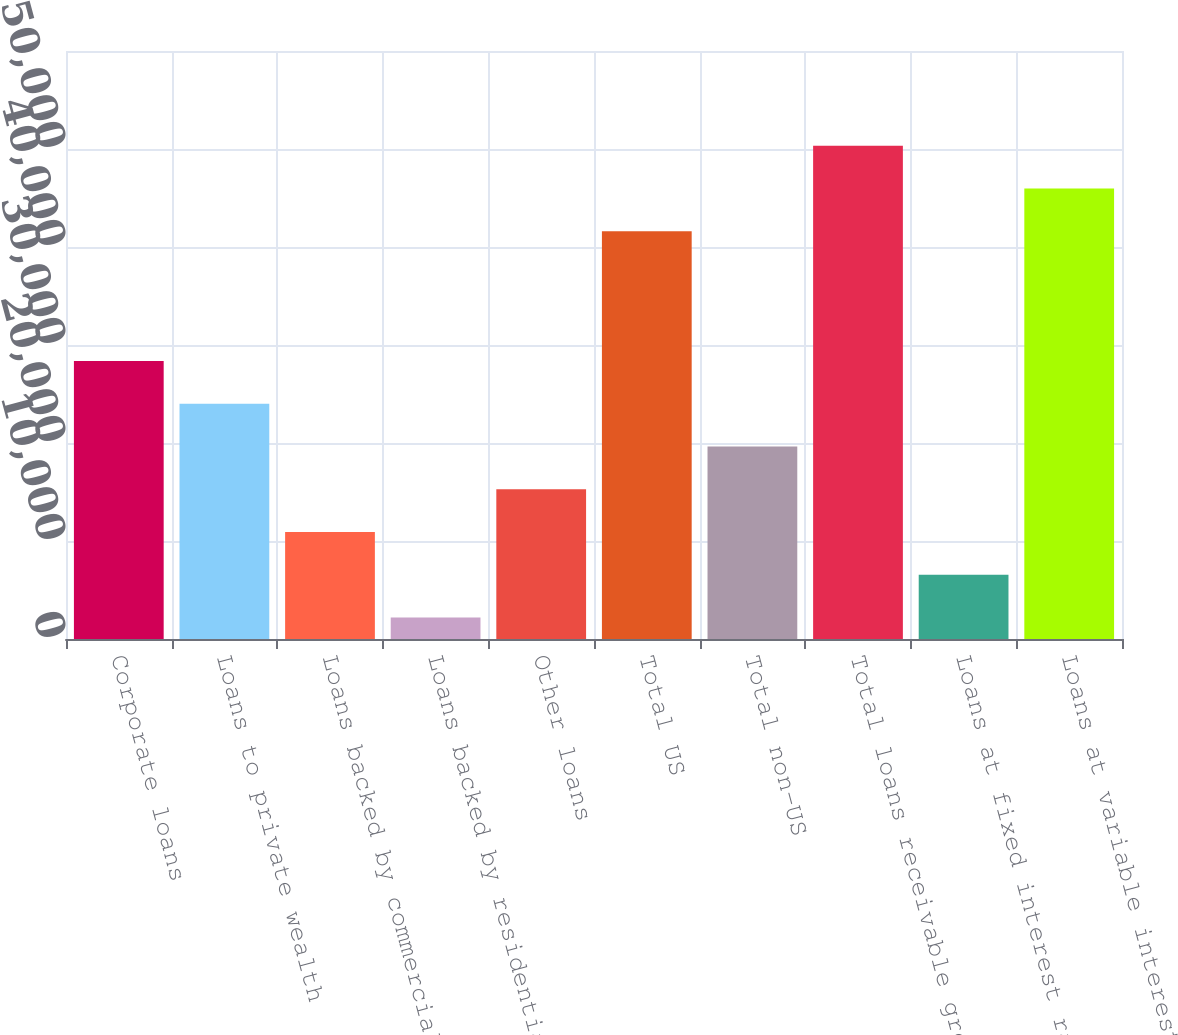Convert chart to OTSL. <chart><loc_0><loc_0><loc_500><loc_500><bar_chart><fcel>Corporate loans<fcel>Loans to private wealth<fcel>Loans backed by commercial<fcel>Loans backed by residential<fcel>Other loans<fcel>Total US<fcel>Total non-US<fcel>Total loans receivable gross<fcel>Loans at fixed interest rates<fcel>Loans at variable interest<nl><fcel>28367.4<fcel>24004<fcel>10913.8<fcel>2187<fcel>15277.2<fcel>41601<fcel>19640.6<fcel>50327.8<fcel>6550.4<fcel>45964.4<nl></chart> 